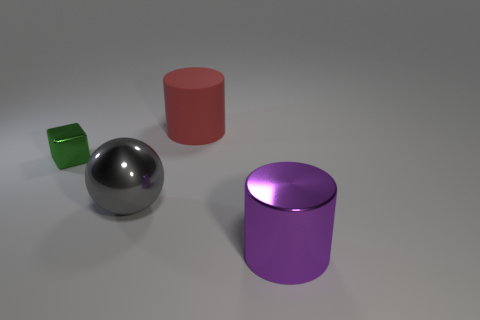Add 3 big red rubber things. How many objects exist? 7 Subtract all blocks. How many objects are left? 3 Add 3 gray metallic spheres. How many gray metallic spheres are left? 4 Add 3 large shiny things. How many large shiny things exist? 5 Subtract 1 gray balls. How many objects are left? 3 Subtract all brown balls. Subtract all gray cubes. How many balls are left? 1 Subtract all small blocks. Subtract all gray metal things. How many objects are left? 2 